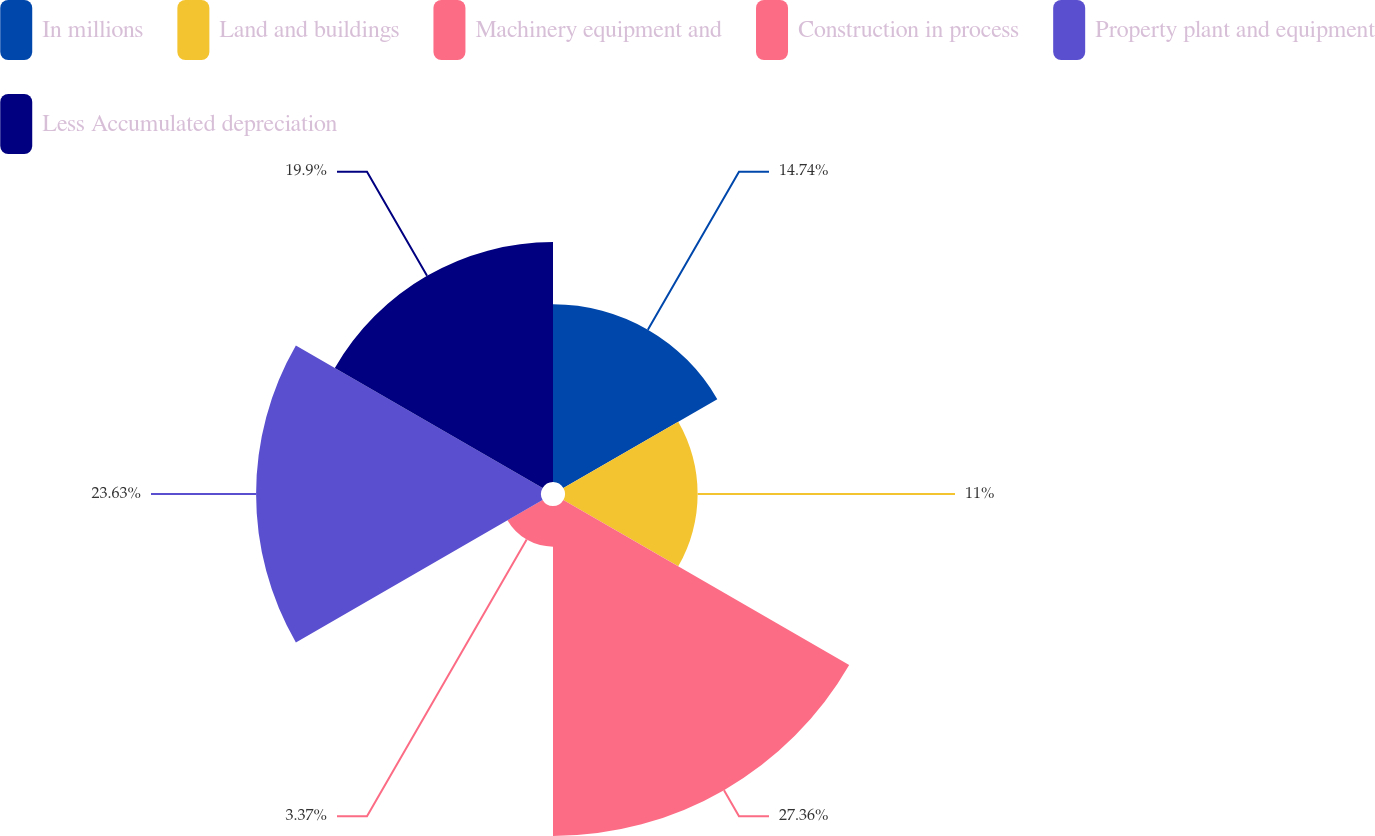<chart> <loc_0><loc_0><loc_500><loc_500><pie_chart><fcel>In millions<fcel>Land and buildings<fcel>Machinery equipment and<fcel>Construction in process<fcel>Property plant and equipment<fcel>Less Accumulated depreciation<nl><fcel>14.74%<fcel>11.0%<fcel>27.37%<fcel>3.37%<fcel>23.63%<fcel>19.9%<nl></chart> 